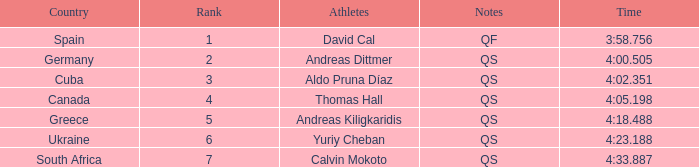What are the notes for the athlete from South Africa? QS. 